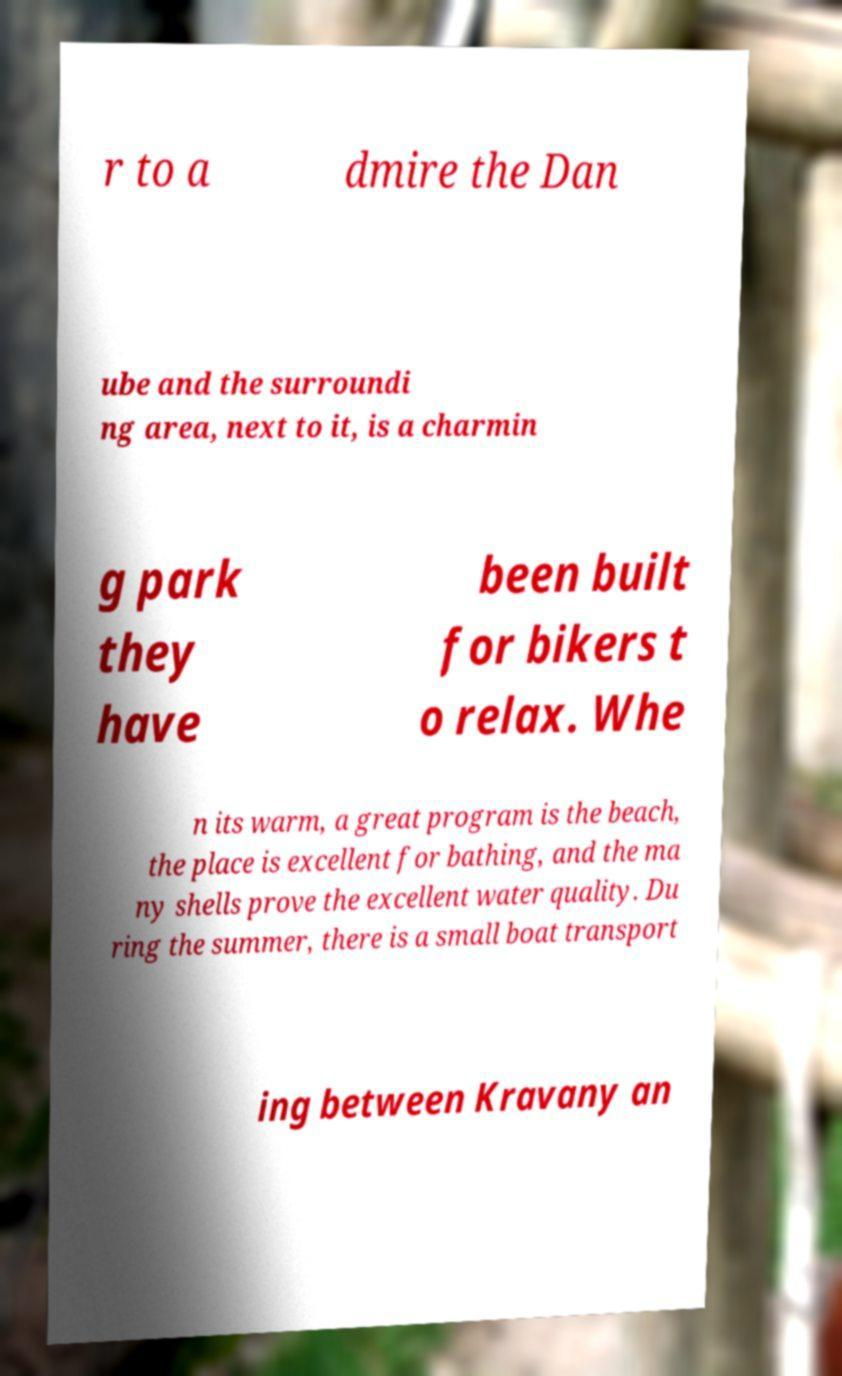Could you assist in decoding the text presented in this image and type it out clearly? r to a dmire the Dan ube and the surroundi ng area, next to it, is a charmin g park they have been built for bikers t o relax. Whe n its warm, a great program is the beach, the place is excellent for bathing, and the ma ny shells prove the excellent water quality. Du ring the summer, there is a small boat transport ing between Kravany an 